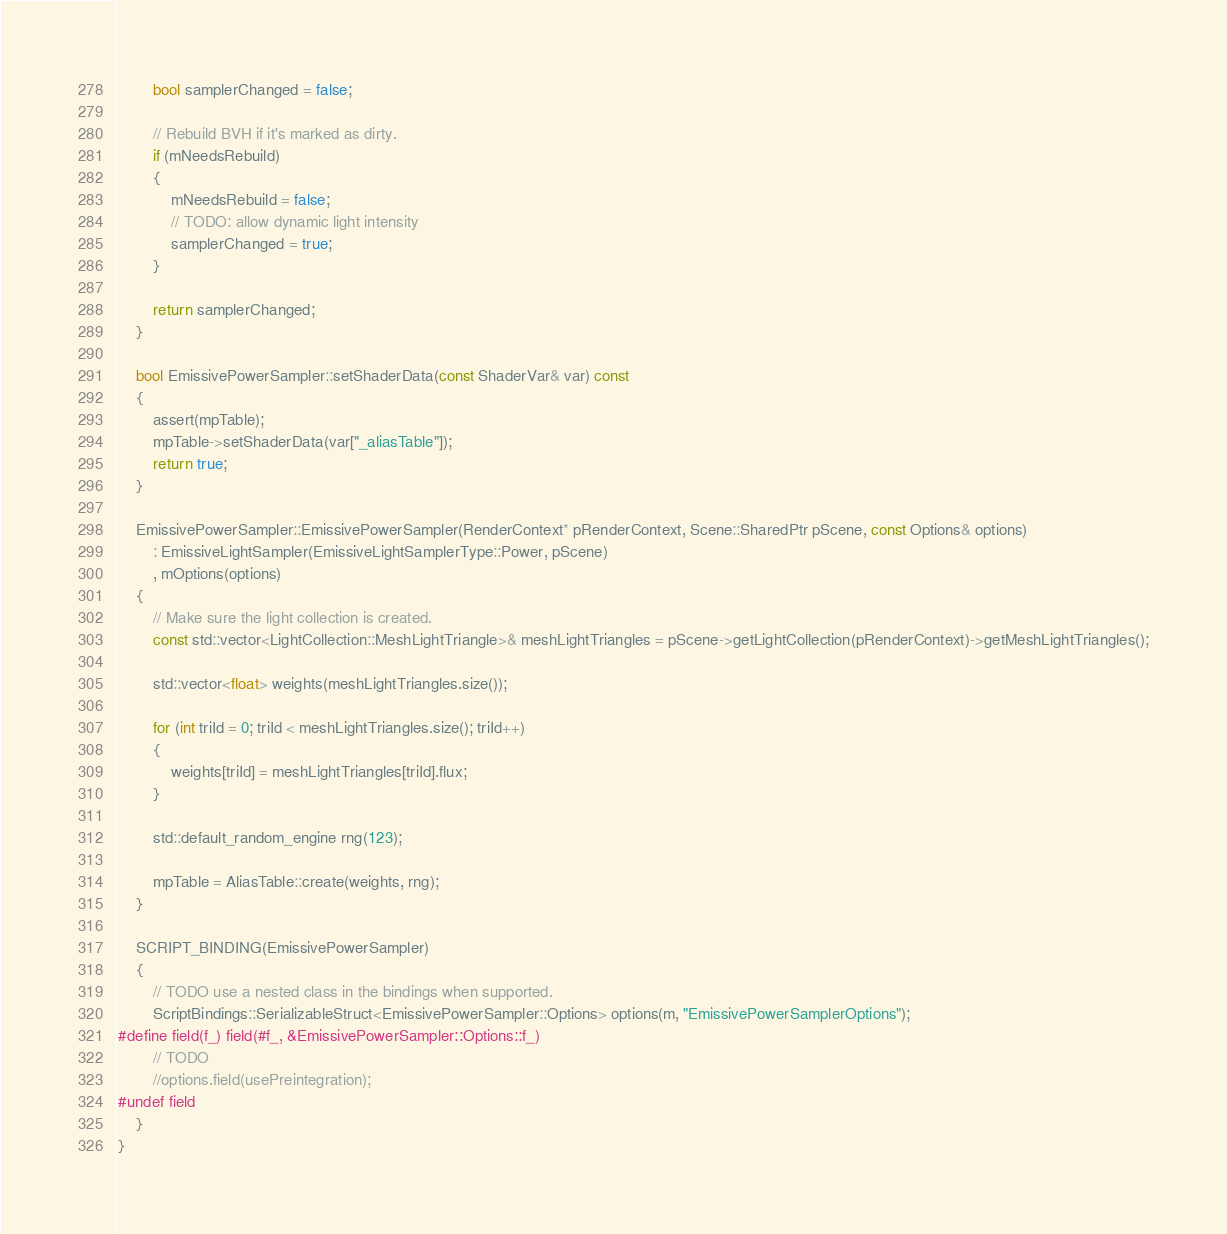<code> <loc_0><loc_0><loc_500><loc_500><_C++_>
        bool samplerChanged = false;

        // Rebuild BVH if it's marked as dirty.
        if (mNeedsRebuild)
        {
            mNeedsRebuild = false;
            // TODO: allow dynamic light intensity
            samplerChanged = true;
        }

        return samplerChanged;
    }

    bool EmissivePowerSampler::setShaderData(const ShaderVar& var) const
    {
        assert(mpTable);
        mpTable->setShaderData(var["_aliasTable"]);
        return true;
    }

    EmissivePowerSampler::EmissivePowerSampler(RenderContext* pRenderContext, Scene::SharedPtr pScene, const Options& options)
        : EmissiveLightSampler(EmissiveLightSamplerType::Power, pScene)
        , mOptions(options)
    {
        // Make sure the light collection is created.
        const std::vector<LightCollection::MeshLightTriangle>& meshLightTriangles = pScene->getLightCollection(pRenderContext)->getMeshLightTriangles();

        std::vector<float> weights(meshLightTriangles.size());

        for (int triId = 0; triId < meshLightTriangles.size(); triId++)
        {
            weights[triId] = meshLightTriangles[triId].flux;
        }

        std::default_random_engine rng(123);

        mpTable = AliasTable::create(weights, rng);
    }

    SCRIPT_BINDING(EmissivePowerSampler)
    {
        // TODO use a nested class in the bindings when supported.
        ScriptBindings::SerializableStruct<EmissivePowerSampler::Options> options(m, "EmissivePowerSamplerOptions");
#define field(f_) field(#f_, &EmissivePowerSampler::Options::f_)
        // TODO
        //options.field(usePreintegration);
#undef field
    }
}
</code> 